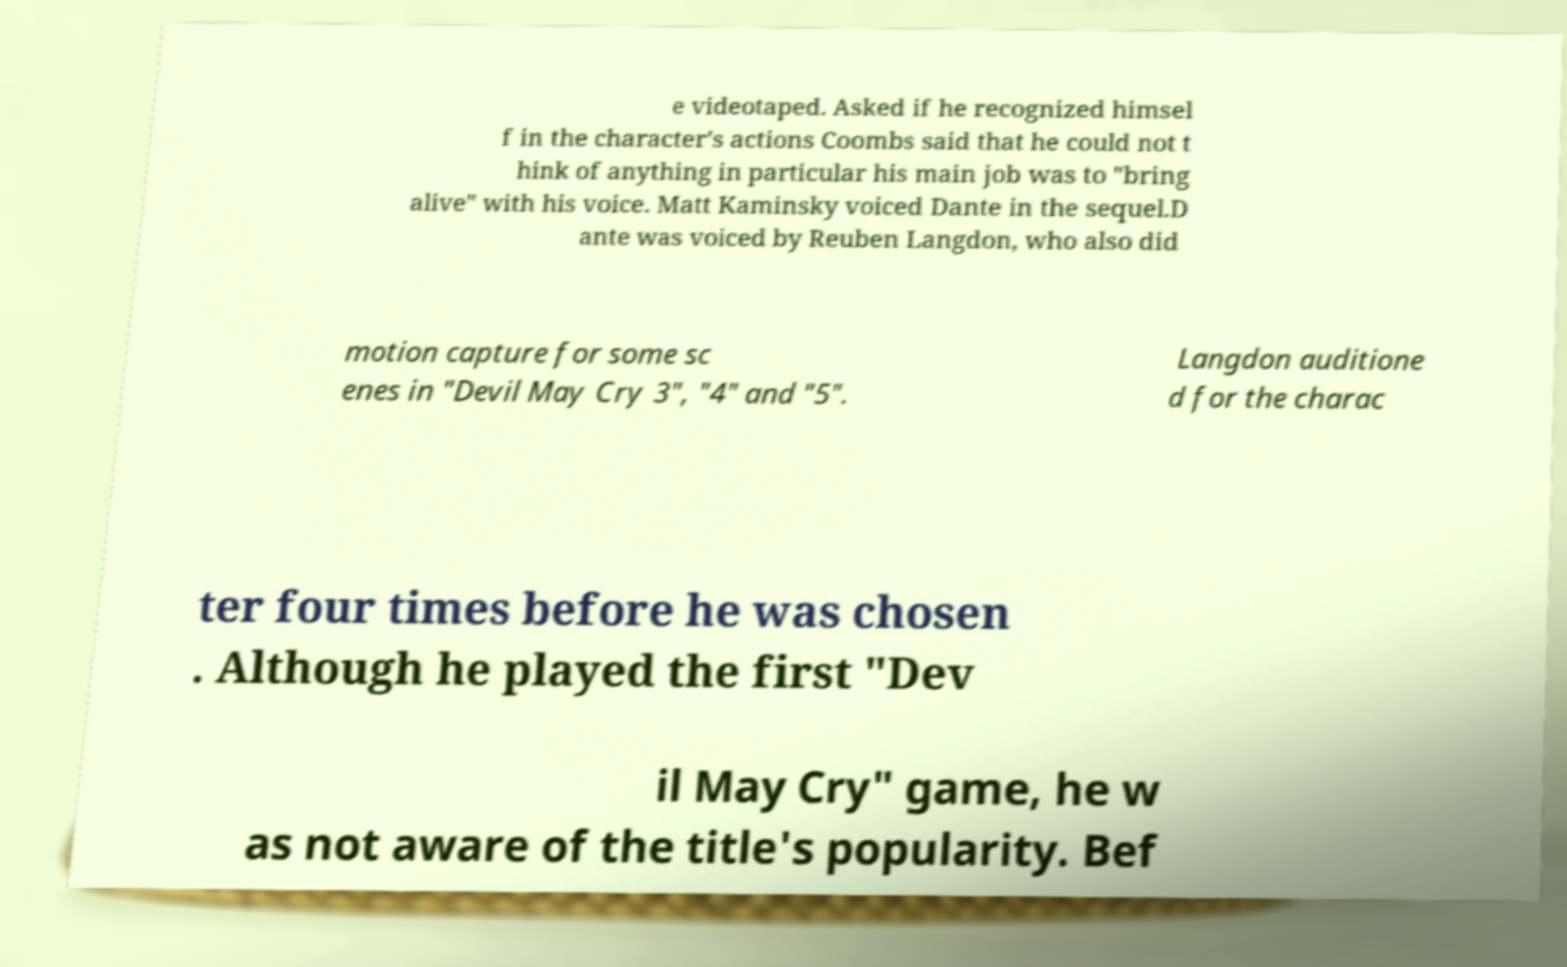Can you read and provide the text displayed in the image?This photo seems to have some interesting text. Can you extract and type it out for me? e videotaped. Asked if he recognized himsel f in the character's actions Coombs said that he could not t hink of anything in particular his main job was to "bring alive" with his voice. Matt Kaminsky voiced Dante in the sequel.D ante was voiced by Reuben Langdon, who also did motion capture for some sc enes in "Devil May Cry 3", "4" and "5". Langdon auditione d for the charac ter four times before he was chosen . Although he played the first "Dev il May Cry" game, he w as not aware of the title's popularity. Bef 